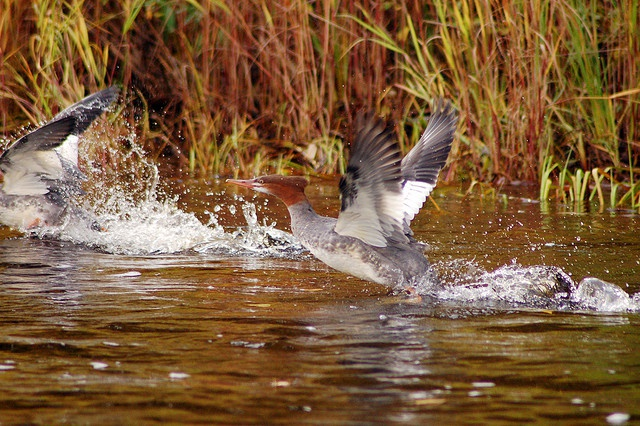Describe the objects in this image and their specific colors. I can see bird in olive, darkgray, gray, and maroon tones and bird in olive, darkgray, gray, and lightgray tones in this image. 